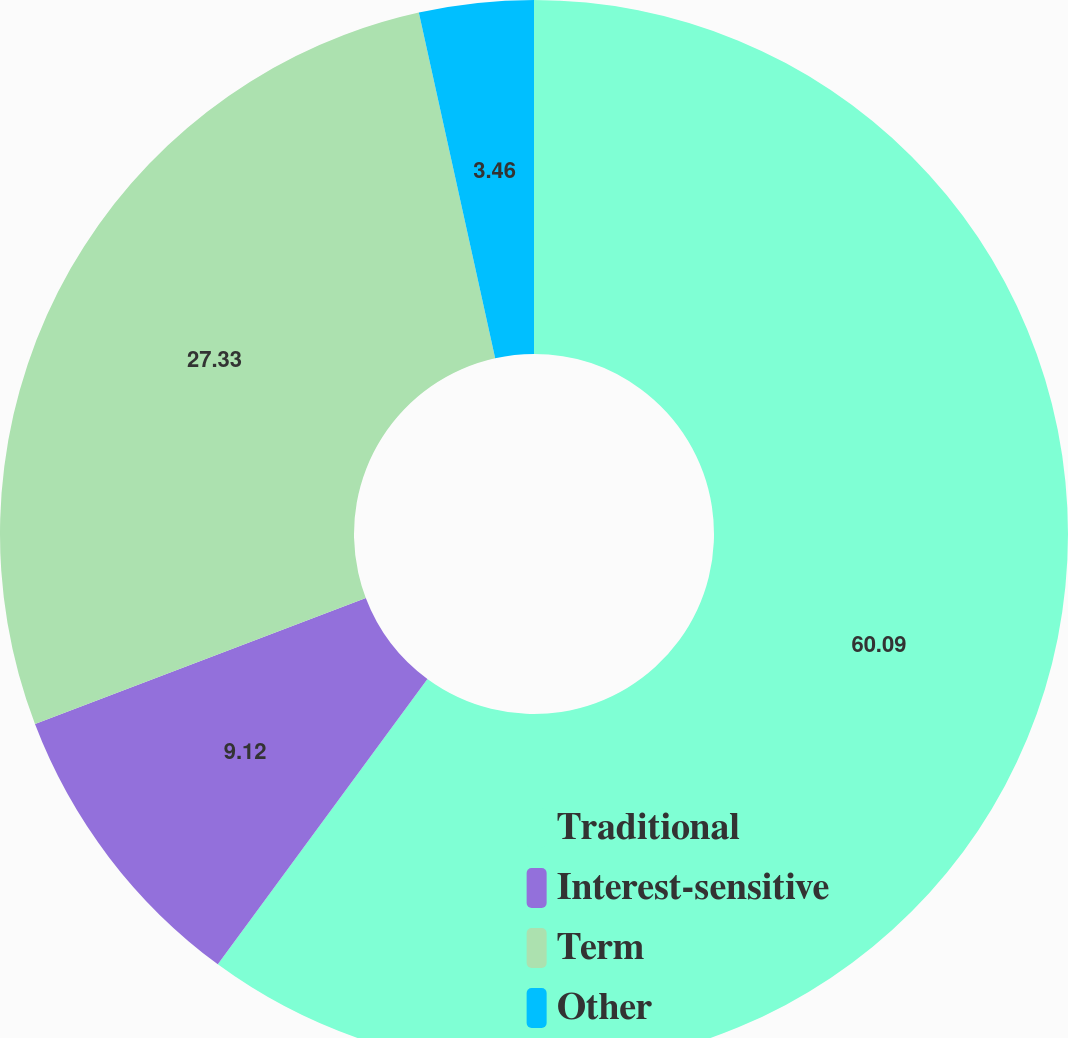Convert chart. <chart><loc_0><loc_0><loc_500><loc_500><pie_chart><fcel>Traditional<fcel>Interest-sensitive<fcel>Term<fcel>Other<nl><fcel>60.08%<fcel>9.12%<fcel>27.33%<fcel>3.46%<nl></chart> 